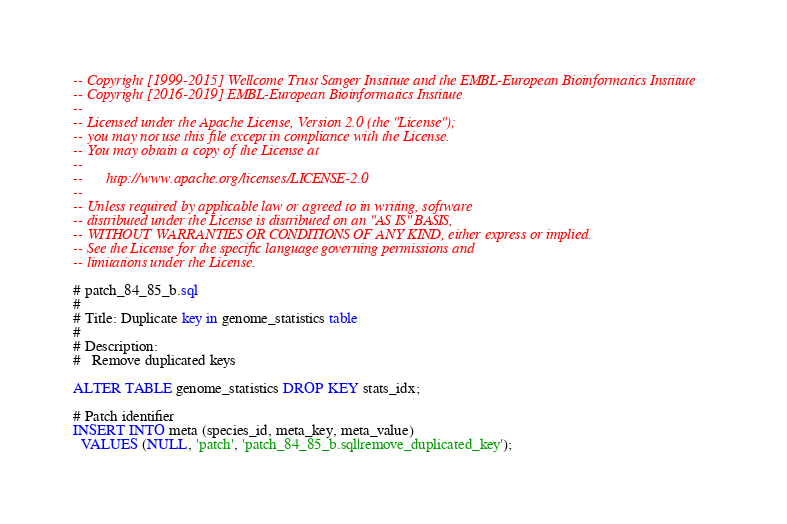Convert code to text. <code><loc_0><loc_0><loc_500><loc_500><_SQL_>-- Copyright [1999-2015] Wellcome Trust Sanger Institute and the EMBL-European Bioinformatics Institute
-- Copyright [2016-2019] EMBL-European Bioinformatics Institute
-- 
-- Licensed under the Apache License, Version 2.0 (the "License");
-- you may not use this file except in compliance with the License.
-- You may obtain a copy of the License at
-- 
--      http://www.apache.org/licenses/LICENSE-2.0
-- 
-- Unless required by applicable law or agreed to in writing, software
-- distributed under the License is distributed on an "AS IS" BASIS,
-- WITHOUT WARRANTIES OR CONDITIONS OF ANY KIND, either express or implied.
-- See the License for the specific language governing permissions and
-- limitations under the License.

# patch_84_85_b.sql
#
# Title: Duplicate key in genome_statistics table
#
# Description:
#   Remove duplicated keys

ALTER TABLE genome_statistics DROP KEY stats_idx;

# Patch identifier
INSERT INTO meta (species_id, meta_key, meta_value)
  VALUES (NULL, 'patch', 'patch_84_85_b.sql|remove_duplicated_key');
</code> 